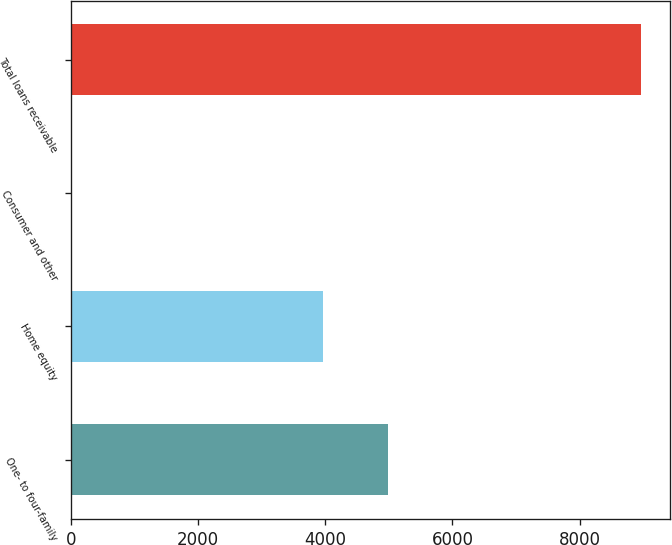<chart> <loc_0><loc_0><loc_500><loc_500><bar_chart><fcel>One- to four-family<fcel>Home equity<fcel>Consumer and other<fcel>Total loans receivable<nl><fcel>4988.5<fcel>3969.8<fcel>13.9<fcel>8972.2<nl></chart> 